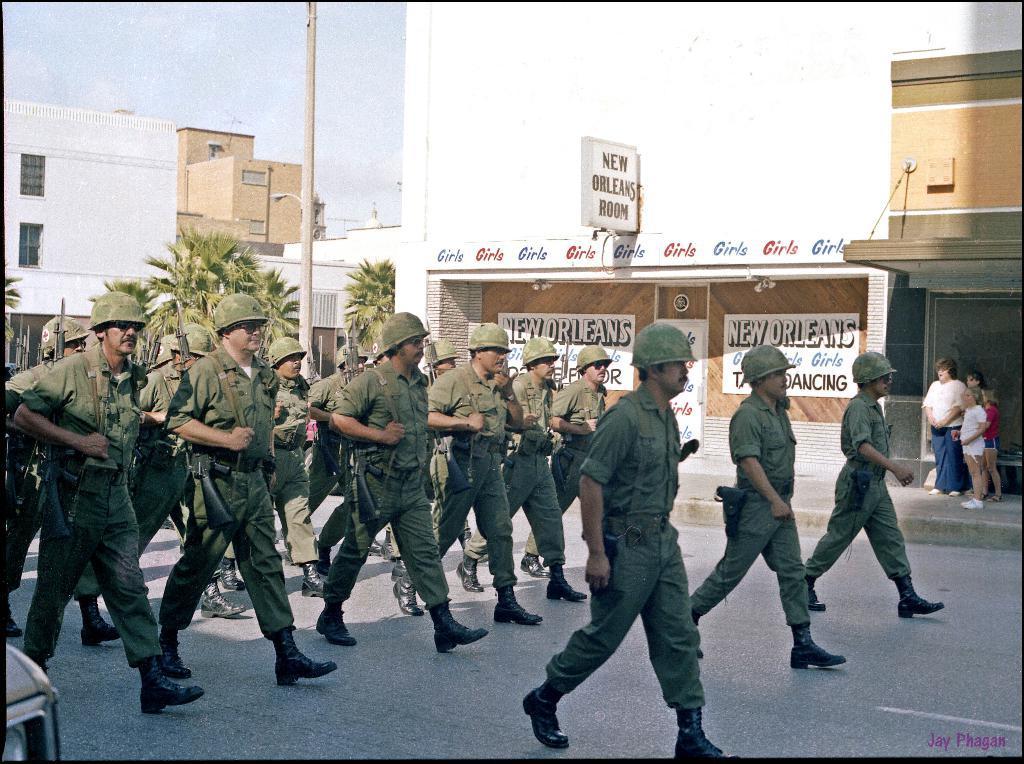How would you summarize this image in a sentence or two? In this image, we can see a group of people in a military dress are walking on the road. Right side bottom corner, we can see a watermark. Background we can see few buildings, houses, trees, pole, walls, windows, posters and sky. Right side of the image, there are few people are standing on the walkway. 